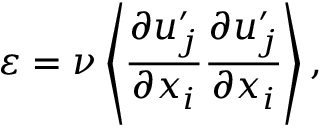<formula> <loc_0><loc_0><loc_500><loc_500>\varepsilon = \nu \left \langle { \frac { \partial u _ { j } ^ { \prime } } { \partial x _ { i } } \frac { \partial u _ { j } ^ { \prime } } { \partial x _ { i } } } \right \rangle ,</formula> 